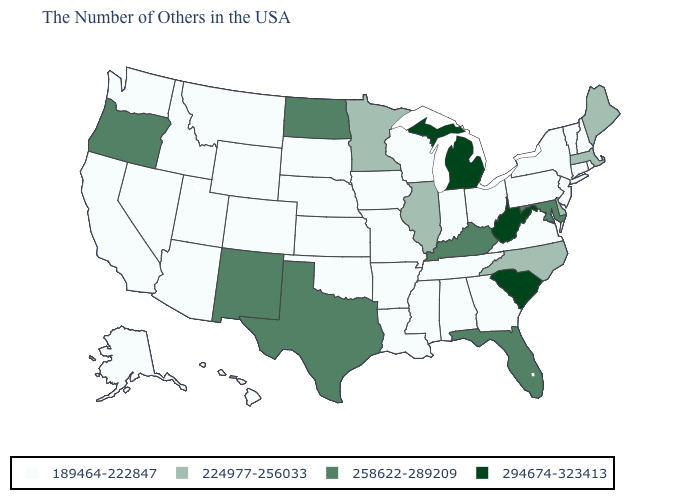Which states have the lowest value in the USA?
Short answer required. Rhode Island, New Hampshire, Vermont, Connecticut, New York, New Jersey, Pennsylvania, Virginia, Ohio, Georgia, Indiana, Alabama, Tennessee, Wisconsin, Mississippi, Louisiana, Missouri, Arkansas, Iowa, Kansas, Nebraska, Oklahoma, South Dakota, Wyoming, Colorado, Utah, Montana, Arizona, Idaho, Nevada, California, Washington, Alaska, Hawaii. What is the lowest value in the USA?
Short answer required. 189464-222847. Which states hav the highest value in the West?
Write a very short answer. New Mexico, Oregon. Does the first symbol in the legend represent the smallest category?
Write a very short answer. Yes. Name the states that have a value in the range 258622-289209?
Give a very brief answer. Maryland, Florida, Kentucky, Texas, North Dakota, New Mexico, Oregon. What is the value of Florida?
Write a very short answer. 258622-289209. Does Illinois have the lowest value in the MidWest?
Answer briefly. No. What is the value of Michigan?
Quick response, please. 294674-323413. Among the states that border Arkansas , which have the highest value?
Quick response, please. Texas. What is the value of Alabama?
Give a very brief answer. 189464-222847. Name the states that have a value in the range 189464-222847?
Concise answer only. Rhode Island, New Hampshire, Vermont, Connecticut, New York, New Jersey, Pennsylvania, Virginia, Ohio, Georgia, Indiana, Alabama, Tennessee, Wisconsin, Mississippi, Louisiana, Missouri, Arkansas, Iowa, Kansas, Nebraska, Oklahoma, South Dakota, Wyoming, Colorado, Utah, Montana, Arizona, Idaho, Nevada, California, Washington, Alaska, Hawaii. What is the lowest value in the USA?
Quick response, please. 189464-222847. What is the value of Wisconsin?
Short answer required. 189464-222847. What is the highest value in states that border Oklahoma?
Write a very short answer. 258622-289209. 